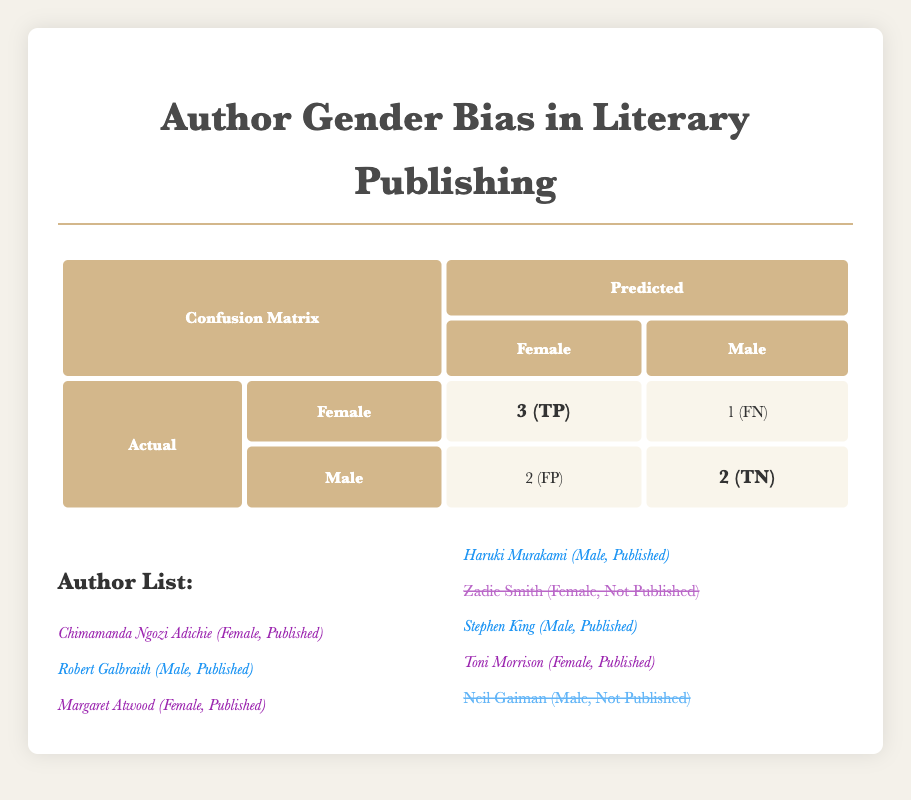What is the total number of True Positives in the confusion matrix? The table indicates that the count of True Positives is directly listed as 3 in the "counts" section of the confusion matrix.
Answer: 3 How many males were incorrectly predicted as females? The count of False Positives indicates the number of males who were predicted as females, which is 2 according to the confusion matrix.
Answer: 2 What is the total number of False Negatives in the confusion matrix? The table displays the count of False Negatives as 1, which is found in the "counts" section under False Negative.
Answer: 1 Is it true that all female authors listed were published? To answer this, I have to check the author list: Zadie Smith is a female author who is marked as not published, which confirms that not all females were published.
Answer: No How many authors in the table are male and published? By examining the author list, Robert Galbraith, Haruki Murakami, and Stephen King are the males who are published. This totals to 3 male authors who are published.
Answer: 3 What percentage of the predictions were True Negatives? The total predictions are the sum of all counts (True Positives + False Positives + True Negatives + False Negatives = 3 + 2 + 2 + 1 = 8). True Negatives are 2, so the percentage is (2/8)*100 = 25%.
Answer: 25% Which group—male or female—has more total published authors based on the list? From the author list, there are 4 published females (Chimamanda Ngozi Adichie, Margaret Atwood, Toni Morrison, and Zadie Smith) and 3 published males (Robert Galbraith, Haruki Murakami, and Stephen King), so females have more published authors.
Answer: Female What is the difference between the True Positives and True Negatives? The number of True Positives is 3, and True Negatives is 2, so the difference is 3 - 2 = 1.
Answer: 1 How many authors listed are not published? In the author list, Zadie Smith and Neil Gaiman are indicated as not published, giving a total count of 2 authors who are not published.
Answer: 2 